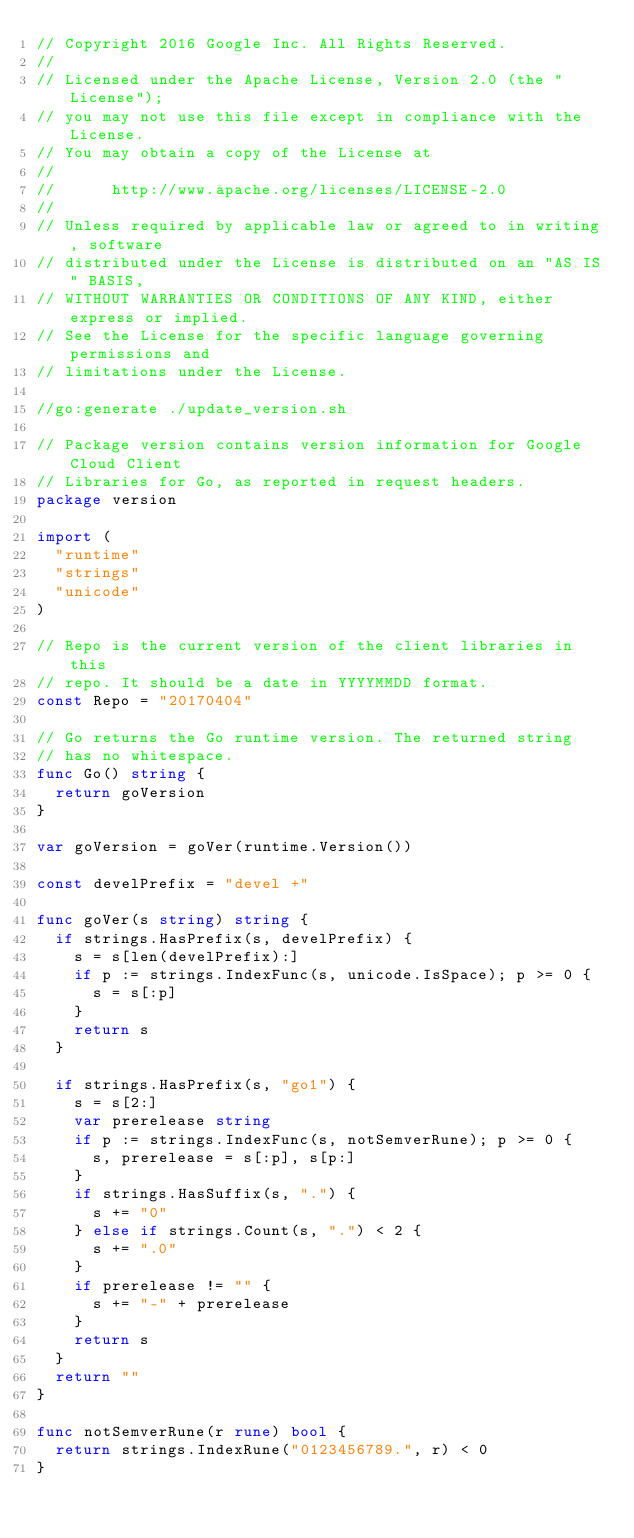Convert code to text. <code><loc_0><loc_0><loc_500><loc_500><_Go_>// Copyright 2016 Google Inc. All Rights Reserved.
//
// Licensed under the Apache License, Version 2.0 (the "License");
// you may not use this file except in compliance with the License.
// You may obtain a copy of the License at
//
//      http://www.apache.org/licenses/LICENSE-2.0
//
// Unless required by applicable law or agreed to in writing, software
// distributed under the License is distributed on an "AS IS" BASIS,
// WITHOUT WARRANTIES OR CONDITIONS OF ANY KIND, either express or implied.
// See the License for the specific language governing permissions and
// limitations under the License.

//go:generate ./update_version.sh

// Package version contains version information for Google Cloud Client
// Libraries for Go, as reported in request headers.
package version

import (
	"runtime"
	"strings"
	"unicode"
)

// Repo is the current version of the client libraries in this
// repo. It should be a date in YYYYMMDD format.
const Repo = "20170404"

// Go returns the Go runtime version. The returned string
// has no whitespace.
func Go() string {
	return goVersion
}

var goVersion = goVer(runtime.Version())

const develPrefix = "devel +"

func goVer(s string) string {
	if strings.HasPrefix(s, develPrefix) {
		s = s[len(develPrefix):]
		if p := strings.IndexFunc(s, unicode.IsSpace); p >= 0 {
			s = s[:p]
		}
		return s
	}

	if strings.HasPrefix(s, "go1") {
		s = s[2:]
		var prerelease string
		if p := strings.IndexFunc(s, notSemverRune); p >= 0 {
			s, prerelease = s[:p], s[p:]
		}
		if strings.HasSuffix(s, ".") {
			s += "0"
		} else if strings.Count(s, ".") < 2 {
			s += ".0"
		}
		if prerelease != "" {
			s += "-" + prerelease
		}
		return s
	}
	return ""
}

func notSemverRune(r rune) bool {
	return strings.IndexRune("0123456789.", r) < 0
}
</code> 